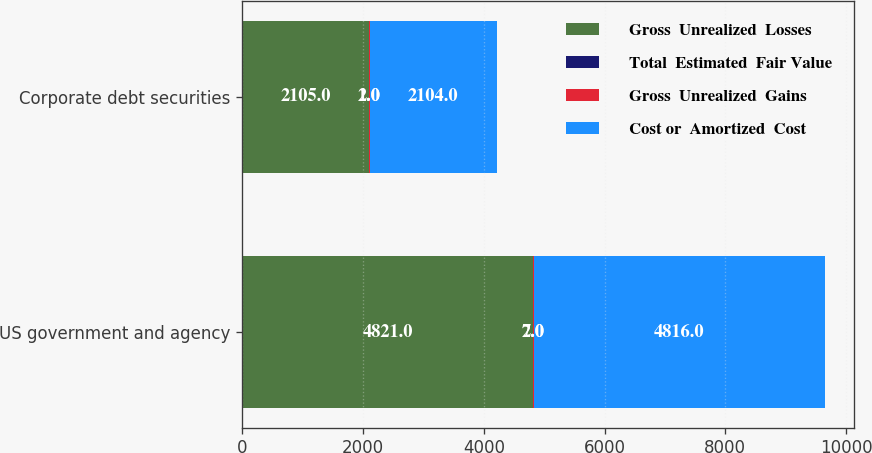<chart> <loc_0><loc_0><loc_500><loc_500><stacked_bar_chart><ecel><fcel>US government and agency<fcel>Corporate debt securities<nl><fcel>Gross  Unrealized  Losses<fcel>4821<fcel>2105<nl><fcel>Total  Estimated  Fair Value<fcel>2<fcel>1<nl><fcel>Gross  Unrealized  Gains<fcel>7<fcel>2<nl><fcel>Cost or  Amortized  Cost<fcel>4816<fcel>2104<nl></chart> 